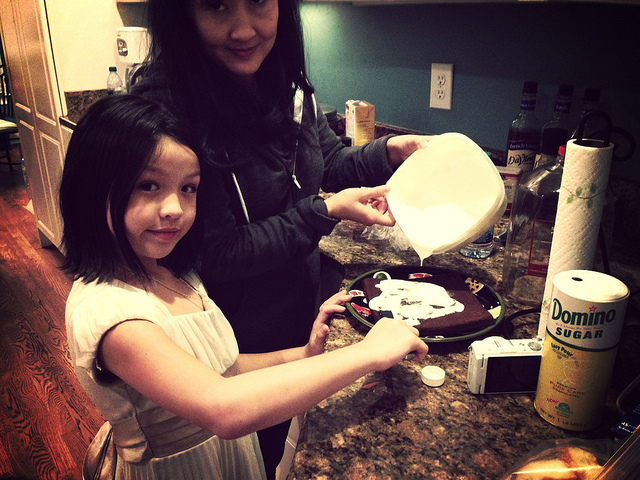Identify the text displayed in this image. Domino SUGAR 